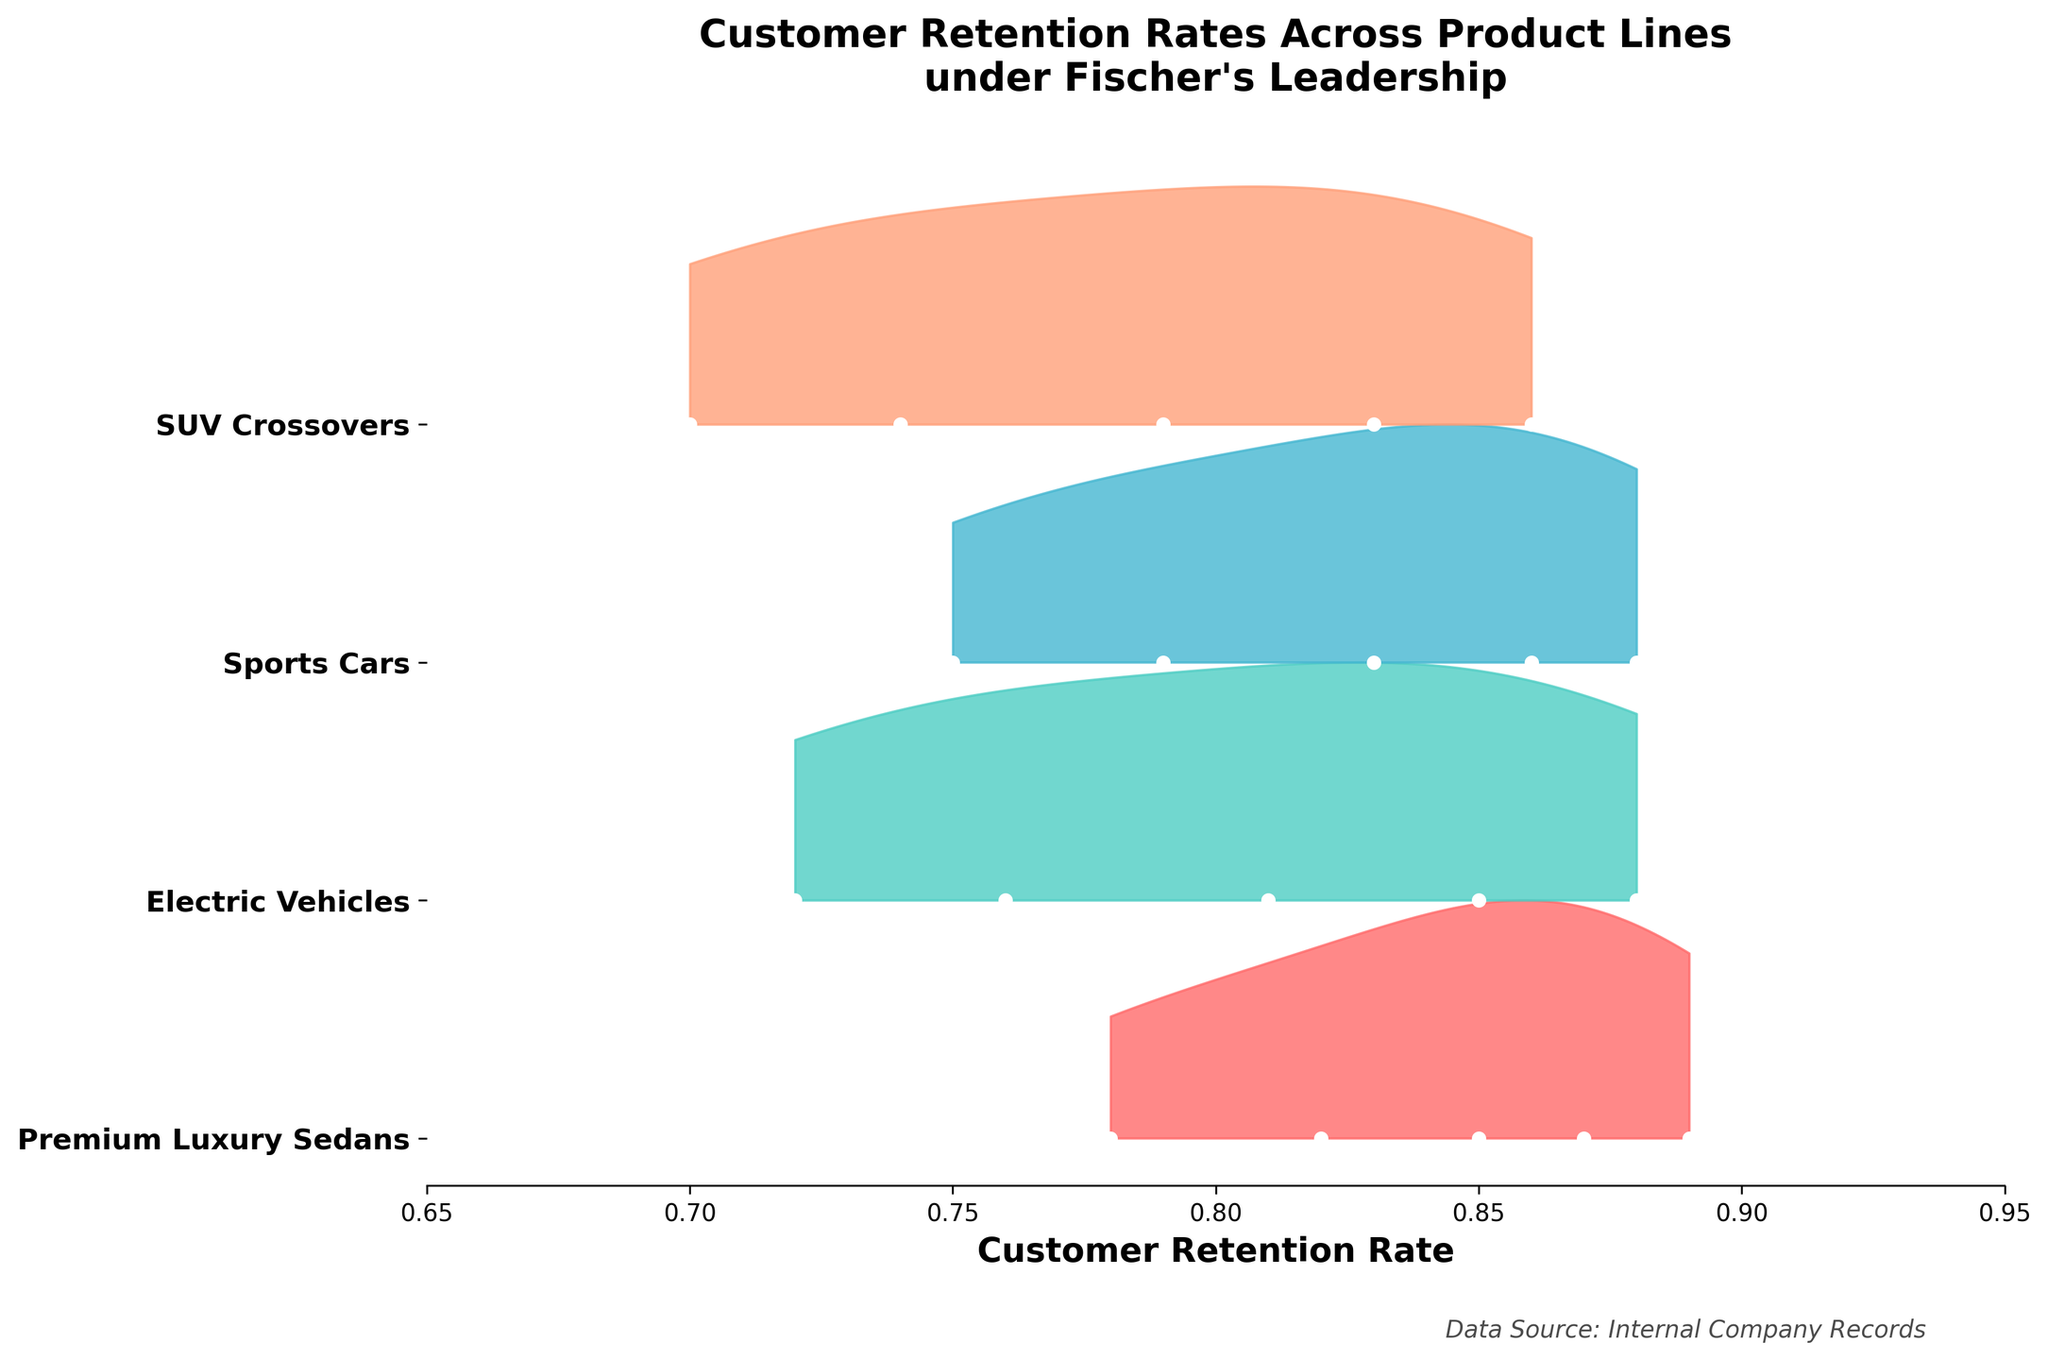what is the title of the figure? The title is typically found at the top of the figure and provides a brief description of what the figure is about. In this case, it summarizes that the figure shows customer retention rates across different product lines introduced under Fischer's leadership.
Answer: Customer Retention Rates Across Product Lines under Fischer's Leadership How many different product lines are represented in the figure? Each product line likely has a distinct area with different fill patterns or colors. By counting these, you determine the number of product lines compared.
Answer: 4 What is the retention rate range covered in the figure? The x-axis is labeled with customer retention rates, and the start and end points of the axis indicate the range.
Answer: 0.65 to 0.95 Which product line shows the lowest retention rate? By looking at the leftmost data points on the x-axis for each product line and comparing them, the lowest rate can be identified.
Answer: SUV Crossovers Which product line shows the highest retention rate? By looking at the rightmost data points on the x-axis for each product line and comparing them, the highest rate can be identified.
Answer: Premium Luxury Sedans What is the retention rate for Electric Vehicles in 2021? Locate the Electric Vehicles product line and check the specific retention rate point for 2021.
Answer: 0.88 Does the retention rate for Sports Cars in 2020 exceed that of Electric Vehicles in 2019? Compare the retention rate points of Sports Cars in 2020 with Electric Vehicles in 2019, checking to see which is higher.
Answer: Yes Which product line has the steepest increase in retention rate over the years? Identify the product line with the greatest upward trend in its retention rate data points over time.
Answer: Typically Electric Vehicles or Sports Cars (detailed comparison may be needed) How does the retention rate for SUV Crossovers in 2020 compare to the retention rate of Premium Luxury Sedans in 2016? Fetch the retention rate value for SUV Crossovers in 2020 and compare it directly with that for Premium Luxury Sedans in 2016.
Answer: SUV Crossovers in 2020 is higher (0.79 compared to 0.82) What is the overall trend in retention rates for Electric Vehicles? Locate the series of points for Electric Vehicles and observe the direction in which they move from the earliest to the latest year.
Answer: Increasing if electric vehicles are seen from 2017 through 2021 